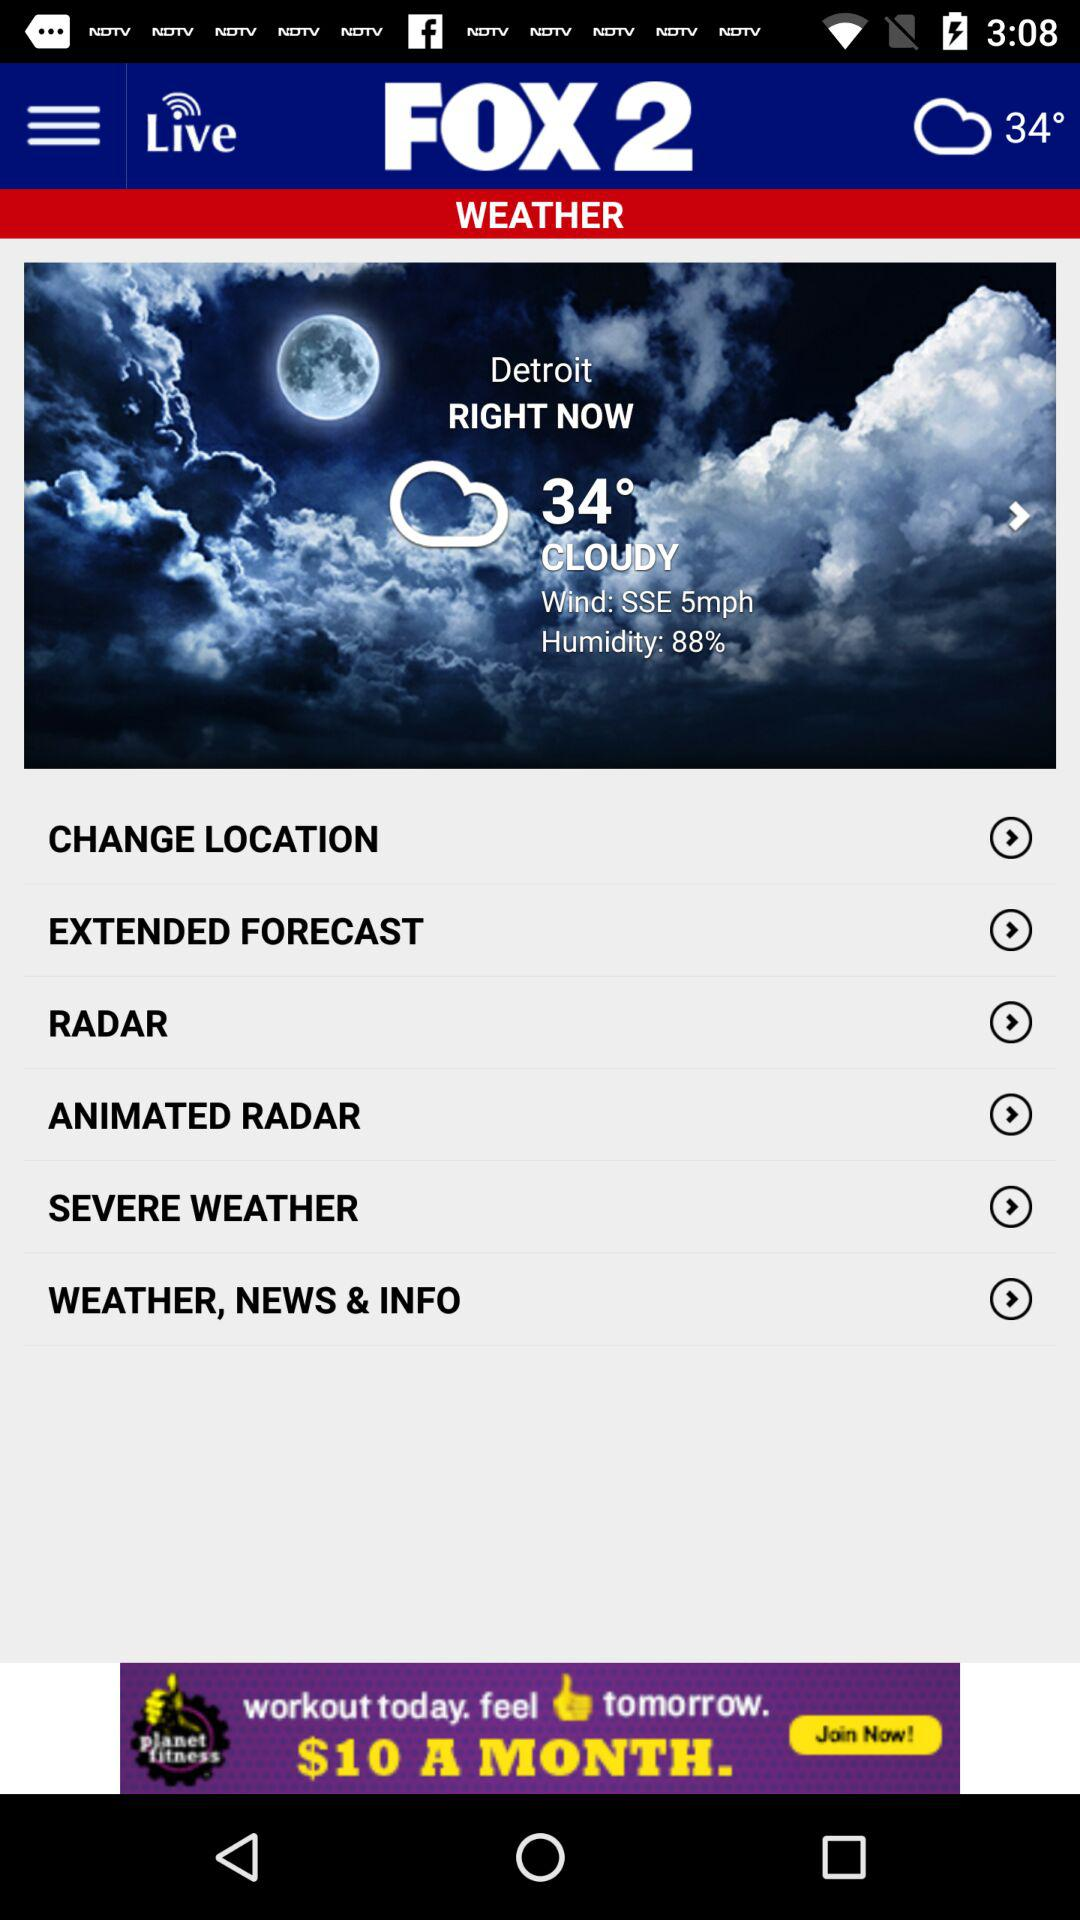What other information can be found on this weather webpage? The webpage offers additional options such as 'CHANGE LOCATION' for localized weather reports, 'EXTENDED FORECAST' to plan ahead with a longer-range outlook, 'RADAR' to view real-time precipitation and weather patterns, 'ANIMATED RADAR' for dynamic weather tracking, 'SEVERE WEATHER' alerts for any urgent weather conditions, and 'WEATHER, NEWS & INFO' for comprehensive updates related to the weather and other news. 